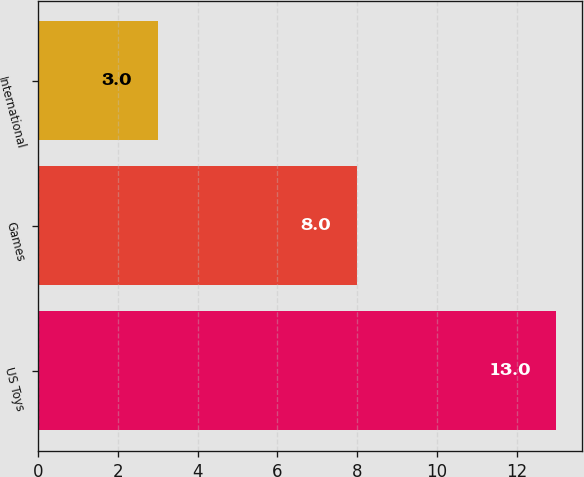Convert chart. <chart><loc_0><loc_0><loc_500><loc_500><bar_chart><fcel>US Toys<fcel>Games<fcel>International<nl><fcel>13<fcel>8<fcel>3<nl></chart> 